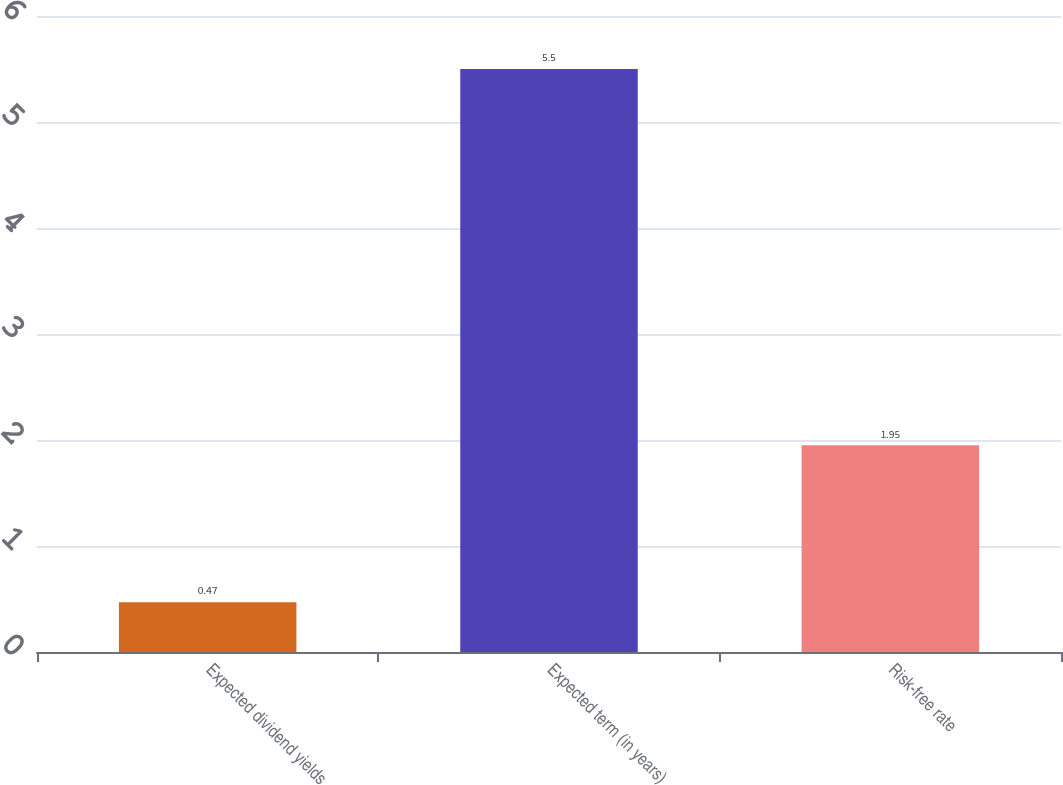Convert chart to OTSL. <chart><loc_0><loc_0><loc_500><loc_500><bar_chart><fcel>Expected dividend yields<fcel>Expected term (in years)<fcel>Risk-free rate<nl><fcel>0.47<fcel>5.5<fcel>1.95<nl></chart> 